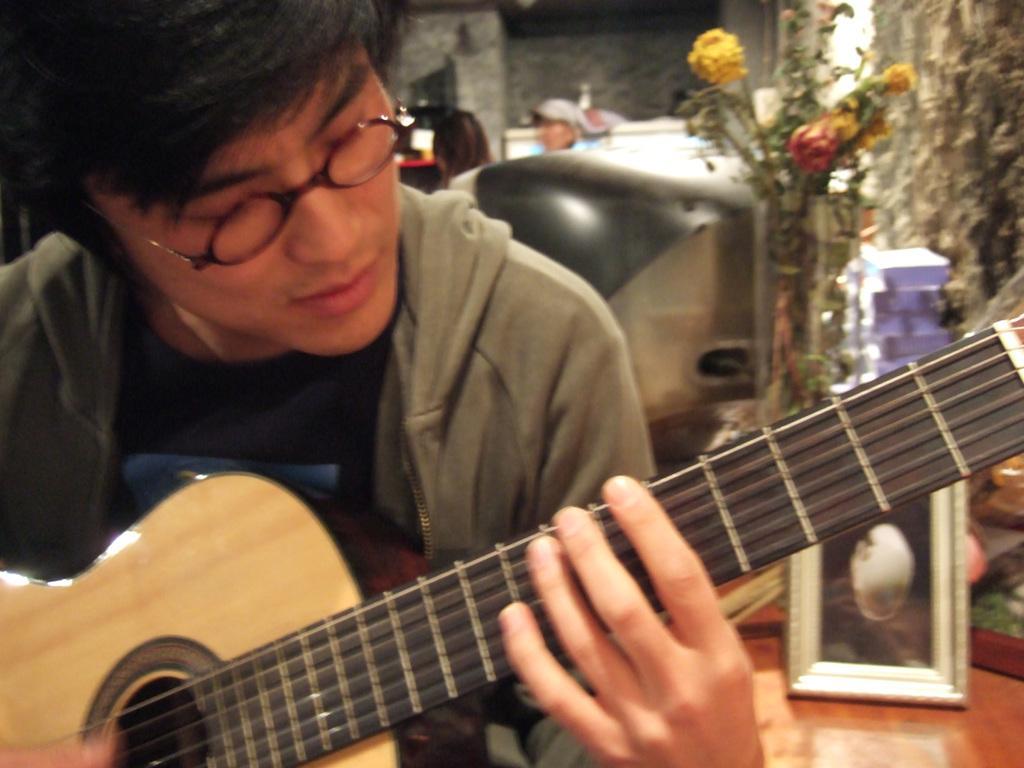Describe this image in one or two sentences. In the left a man is playing guitar he wear a jacket and spectacles ,he is staring at guitar. On the right there is a photo frame and flower vase. In the background there is a wall. 